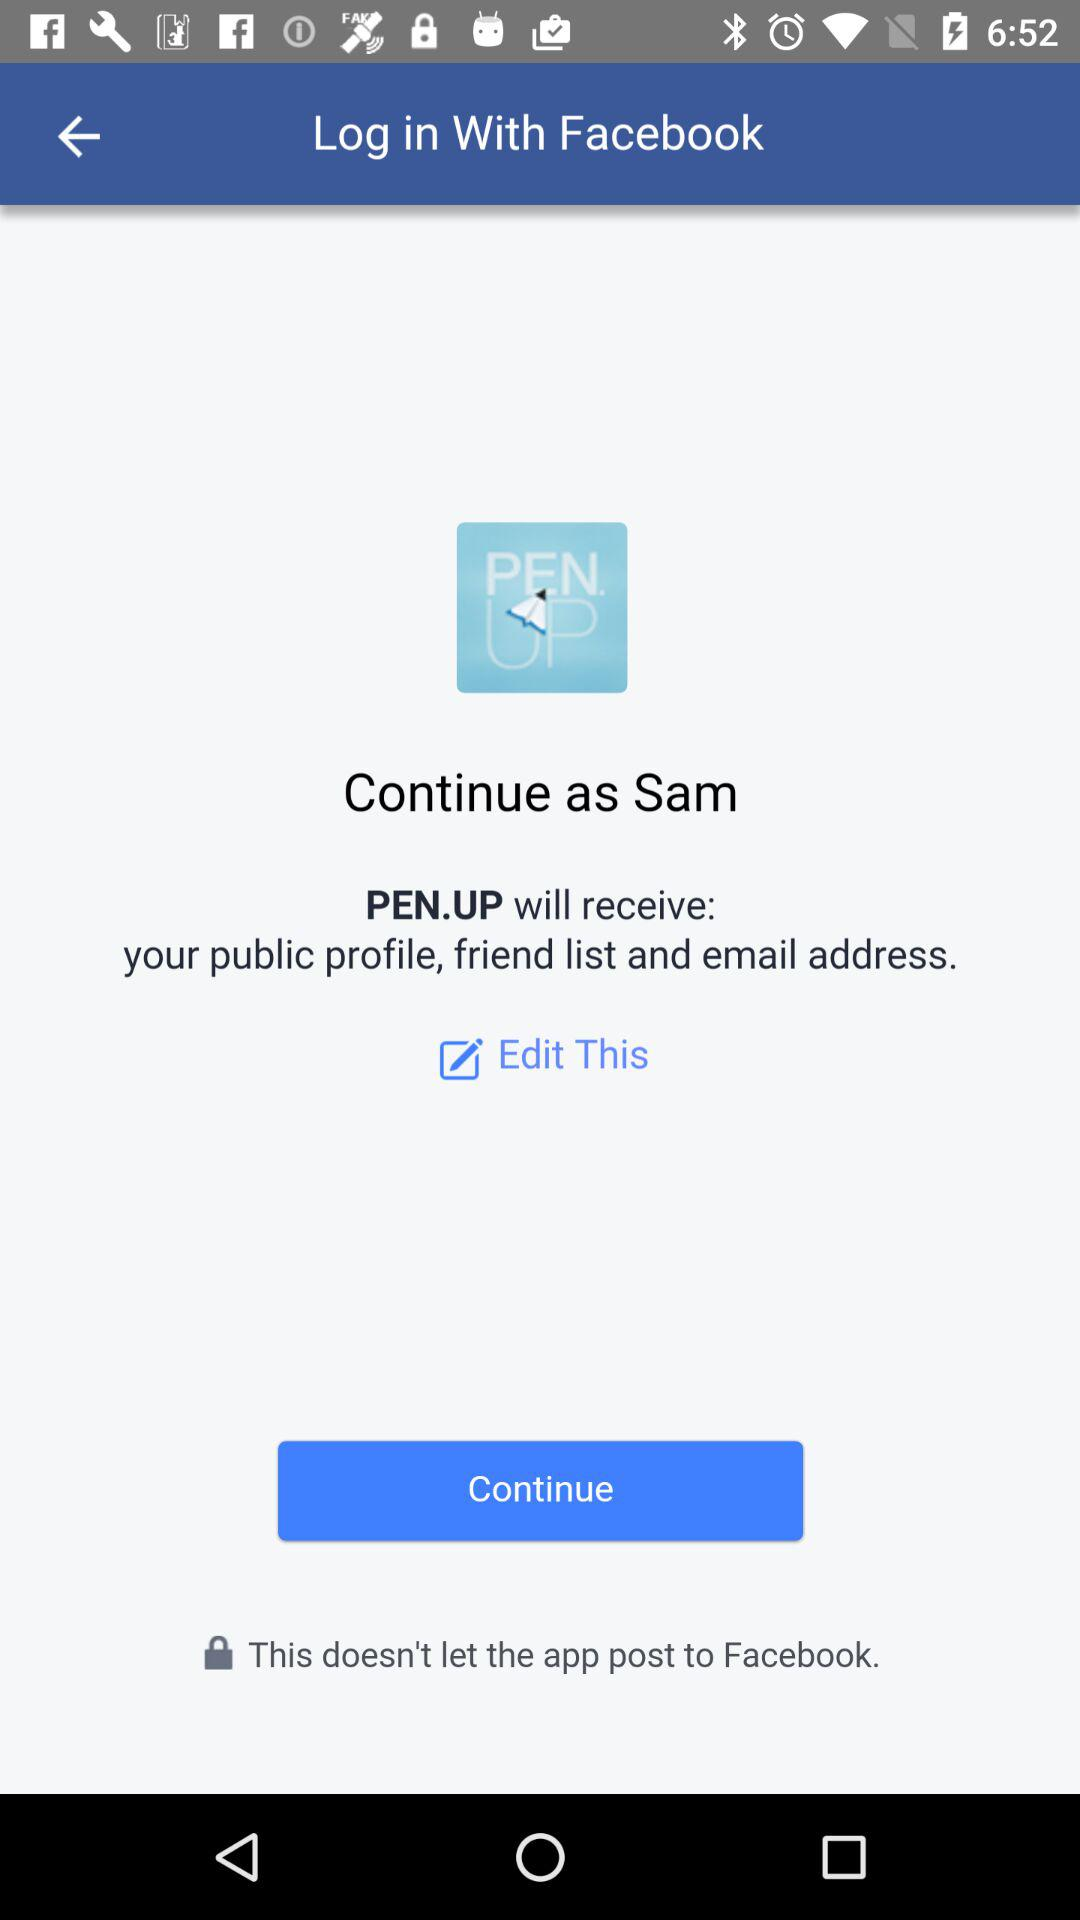What is the name of the user? The name of the user is Sam. 